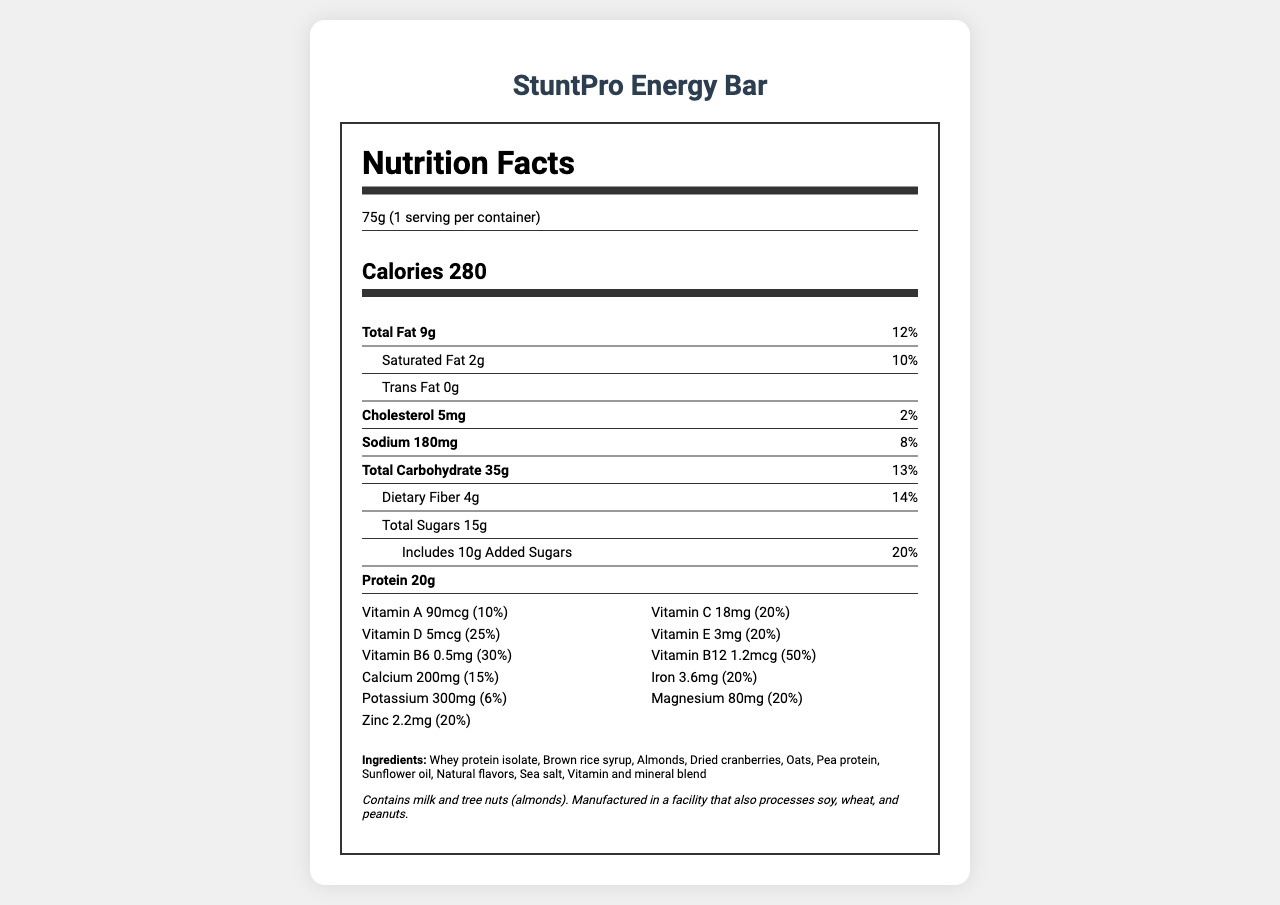what is the serving size of the StuntPro Energy Bar? The serving size is mentioned in the serving info section at the top of the nutrition label.
Answer: 75g how many grams of protein does one serving contain? The amount of protein is listed as 20g in the nutrient info section of the label.
Answer: 20g what is the percentage of daily value for Vitamin B12? The daily value percentage for Vitamin B12 is listed as 50% in the vitamin info section.
Answer: 50% how much dietary fiber does one bar contain? The amount of dietary fiber is listed as 4g in the nutrient info section of the label.
Answer: 4g what are the main ingredients of StuntPro Energy Bar? The ingredients are listed towards the end of the document under the ingredients section.
Answer: Whey protein isolate, Brown rice syrup, Almonds, Dried cranberries, Oats, Pea protein, Sunflower oil, Natural flavors, Sea salt, Vitamin and mineral blend which of the following vitamins has the highest daily value percentage in the StuntPro Energy Bar? A. Vitamin A B. Vitamin D C. Vitamin B6 D. Vitamin B12 The daily value percentage for Vitamin B12 is 50%, which is higher than the other listed vitamins.
Answer: D. Vitamin B12 what is the amount of sodium in one serving of the energy bar? A. 180mg B. 150mg C. 200mg D. 100mg The amount of sodium is listed as 180mg in the nutrient info section of the label.
Answer: A. 180mg is the StuntPro Energy Bar suitable for someone with a peanut allergy? The allergen info states that it is manufactured in a facility that also processes peanuts.
Answer: No does the StuntPro Energy Bar contain any trans fats? The label explicitly states that the trans fat content is 0g.
Answer: No how does this product benefit professional stunt performers? The product description explains that the bar is formulated to support stunt performers' energy levels, muscle recovery, and overall performance.
Answer: The bar provides a balanced mix of protein, carbohydrates, and essential vitamins and minerals to support energy, muscle recovery, and overall performance during intense physical activities. what is the growth rate of the global sports nutrition market mentioned in the investment potential section? The growth rate is listed in the investment potential section of the document.
Answer: Expected CAGR of 10.9% from 2021 to 2028 what is the global sports nutrition market projected to reach by 2028? The market size is mentioned in the investment potential section of the document.
Answer: $34.5 billion what is the purpose of adding vitamins and minerals to the energy bar? The unique selling points state that the bar is fortified with vitamins and minerals to support overall health.
Answer: To support overall health and provide essential nutrients needed for energy and performance. what ingredients are a part of the vitamin and mineral blend in the StuntPro Energy Bar? While the label mentions a "vitamin and mineral blend," it does not specify the individual components of this blend.
Answer: Cannot be determined how much calcium is provided in one serving of the StuntPro Energy Bar? The amount of calcium is listed as 200mg in the vitamin info section of the label.
Answer: 200mg describe the main idea of the StuntPro Energy Bar's nutrition facts document. The document features a comprehensive breakdown of nutritional facts, targeting professional stunt performers, and highlights the benefits and investment potential of the product.
Answer: The document provides detailed nutritional information for the StuntPro Energy Bar, including serving size, calorie content, macronutrient breakdown, vitamin and mineral content, ingredients, and allergen information. It emphasizes the product's benefits for professional stunt performers and mentions the potential market size and growth for sports nutrition products. 